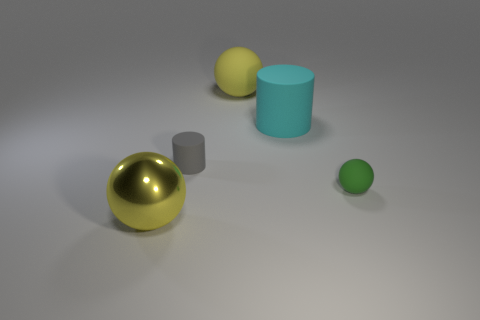How many objects are there and can you describe their textures? There are four objects in the image. Starting with the largest, there is a smooth and slightly reflective matte cyan cylinder, a shiny yellow metallic sphere, a smaller less reflective matte gray cube, and a small green sphere with a matte finish. Which object seems out of place in terms of size? The small green sphere seems out of place in terms of size. It is significantly smaller than the other objects, which gives it a unique presence in the composition of the image. 